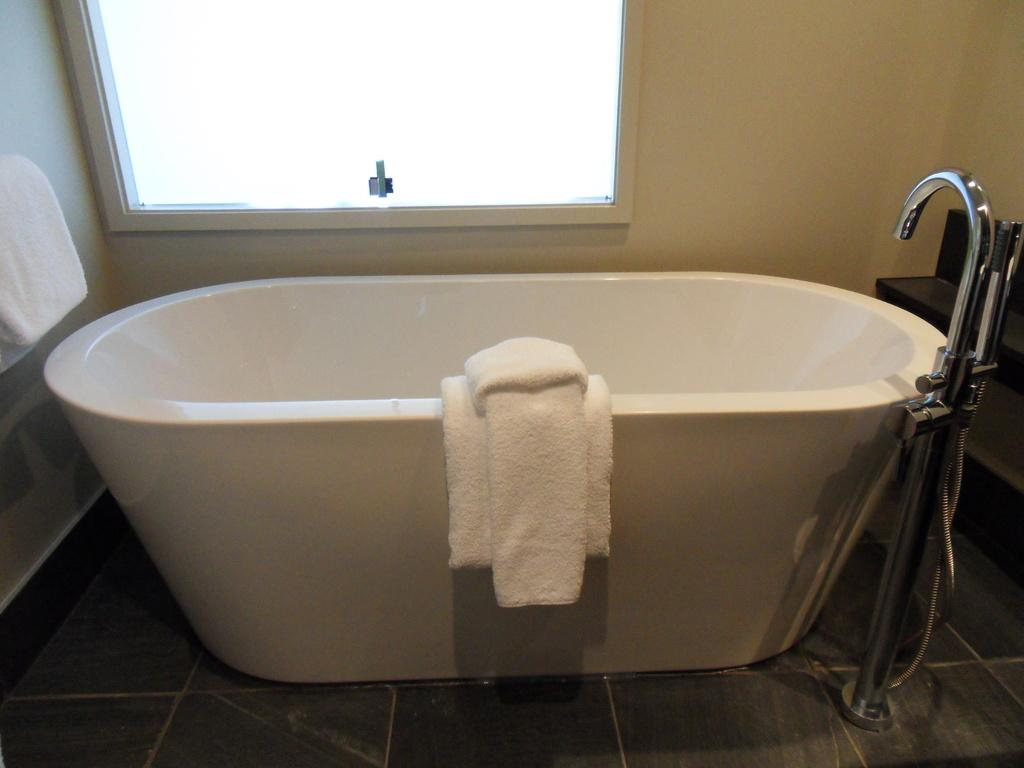What type of room is the image taken in? The image is taken inside a bathroom. What is the main feature of the bathroom? There is a bathtub in the image. What can be seen on the bathtub? There are towels on the bathtub. Are there any other towels in the image? Yes, there is another towel in the image. What can be seen near the bathtub? There is a window in the image. What is used for water in the image? There is a tap in the image. What type of spring can be seen in the image? There is no spring present in the image; it is taken inside a bathroom with a bathtub, towels, a window, and a tap. What kind of soda is being served in the image? There is no soda present in the image; it is focused on the bathroom setting. 